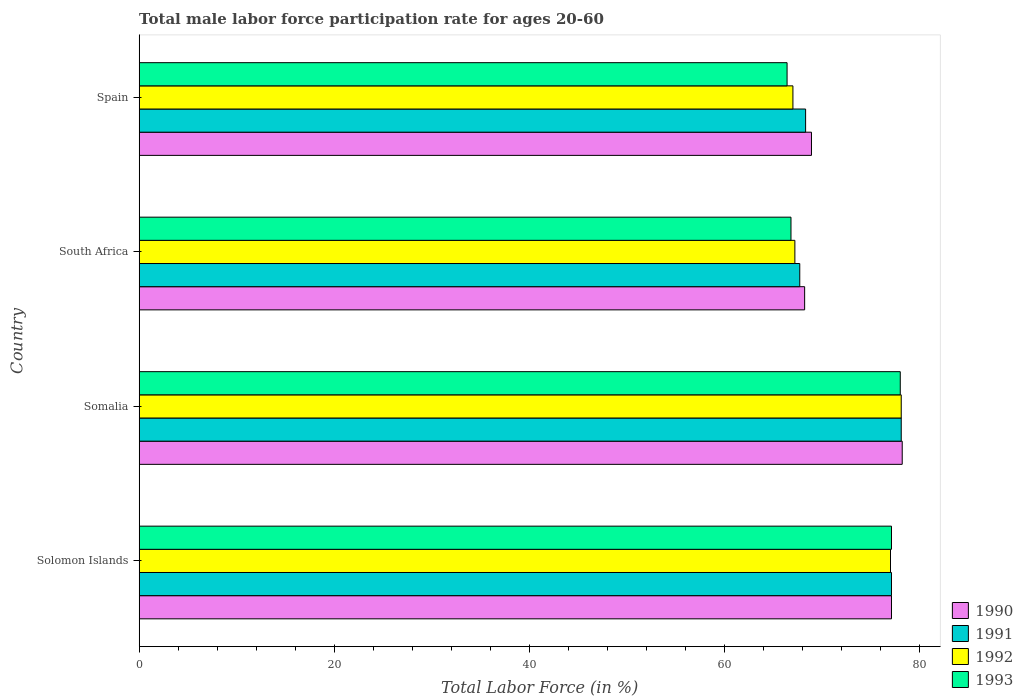How many groups of bars are there?
Ensure brevity in your answer.  4. Are the number of bars on each tick of the Y-axis equal?
Provide a short and direct response. Yes. How many bars are there on the 2nd tick from the bottom?
Provide a short and direct response. 4. What is the label of the 2nd group of bars from the top?
Keep it short and to the point. South Africa. What is the male labor force participation rate in 1992 in Somalia?
Provide a short and direct response. 78.1. Across all countries, what is the minimum male labor force participation rate in 1991?
Provide a succinct answer. 67.7. In which country was the male labor force participation rate in 1993 maximum?
Ensure brevity in your answer.  Somalia. What is the total male labor force participation rate in 1992 in the graph?
Your answer should be compact. 289.3. What is the difference between the male labor force participation rate in 1992 in Solomon Islands and that in Spain?
Your response must be concise. 10. What is the difference between the male labor force participation rate in 1991 in Somalia and the male labor force participation rate in 1993 in South Africa?
Offer a very short reply. 11.3. What is the average male labor force participation rate in 1990 per country?
Your answer should be very brief. 73.1. What is the difference between the male labor force participation rate in 1991 and male labor force participation rate in 1990 in Spain?
Offer a very short reply. -0.6. What is the ratio of the male labor force participation rate in 1993 in Solomon Islands to that in Somalia?
Provide a succinct answer. 0.99. Is the difference between the male labor force participation rate in 1991 in Solomon Islands and Spain greater than the difference between the male labor force participation rate in 1990 in Solomon Islands and Spain?
Offer a terse response. Yes. What is the difference between the highest and the second highest male labor force participation rate in 1992?
Your answer should be very brief. 1.1. In how many countries, is the male labor force participation rate in 1992 greater than the average male labor force participation rate in 1992 taken over all countries?
Your answer should be compact. 2. Is it the case that in every country, the sum of the male labor force participation rate in 1990 and male labor force participation rate in 1992 is greater than the sum of male labor force participation rate in 1993 and male labor force participation rate in 1991?
Provide a succinct answer. No. What does the 3rd bar from the bottom in South Africa represents?
Provide a short and direct response. 1992. Are all the bars in the graph horizontal?
Your answer should be very brief. Yes. Does the graph contain any zero values?
Your response must be concise. No. Does the graph contain grids?
Provide a short and direct response. No. How are the legend labels stacked?
Offer a very short reply. Vertical. What is the title of the graph?
Your answer should be very brief. Total male labor force participation rate for ages 20-60. Does "1983" appear as one of the legend labels in the graph?
Ensure brevity in your answer.  No. What is the label or title of the X-axis?
Make the answer very short. Total Labor Force (in %). What is the Total Labor Force (in %) of 1990 in Solomon Islands?
Ensure brevity in your answer.  77.1. What is the Total Labor Force (in %) of 1991 in Solomon Islands?
Your answer should be very brief. 77.1. What is the Total Labor Force (in %) in 1992 in Solomon Islands?
Your answer should be very brief. 77. What is the Total Labor Force (in %) in 1993 in Solomon Islands?
Give a very brief answer. 77.1. What is the Total Labor Force (in %) of 1990 in Somalia?
Provide a short and direct response. 78.2. What is the Total Labor Force (in %) in 1991 in Somalia?
Your answer should be compact. 78.1. What is the Total Labor Force (in %) of 1992 in Somalia?
Provide a short and direct response. 78.1. What is the Total Labor Force (in %) in 1990 in South Africa?
Ensure brevity in your answer.  68.2. What is the Total Labor Force (in %) of 1991 in South Africa?
Your response must be concise. 67.7. What is the Total Labor Force (in %) of 1992 in South Africa?
Offer a very short reply. 67.2. What is the Total Labor Force (in %) of 1993 in South Africa?
Keep it short and to the point. 66.8. What is the Total Labor Force (in %) of 1990 in Spain?
Your response must be concise. 68.9. What is the Total Labor Force (in %) of 1991 in Spain?
Ensure brevity in your answer.  68.3. What is the Total Labor Force (in %) of 1993 in Spain?
Ensure brevity in your answer.  66.4. Across all countries, what is the maximum Total Labor Force (in %) in 1990?
Ensure brevity in your answer.  78.2. Across all countries, what is the maximum Total Labor Force (in %) in 1991?
Your answer should be compact. 78.1. Across all countries, what is the maximum Total Labor Force (in %) of 1992?
Give a very brief answer. 78.1. Across all countries, what is the maximum Total Labor Force (in %) of 1993?
Offer a terse response. 78. Across all countries, what is the minimum Total Labor Force (in %) of 1990?
Offer a very short reply. 68.2. Across all countries, what is the minimum Total Labor Force (in %) in 1991?
Your answer should be very brief. 67.7. Across all countries, what is the minimum Total Labor Force (in %) of 1992?
Provide a succinct answer. 67. Across all countries, what is the minimum Total Labor Force (in %) in 1993?
Offer a very short reply. 66.4. What is the total Total Labor Force (in %) of 1990 in the graph?
Provide a short and direct response. 292.4. What is the total Total Labor Force (in %) of 1991 in the graph?
Provide a succinct answer. 291.2. What is the total Total Labor Force (in %) of 1992 in the graph?
Provide a succinct answer. 289.3. What is the total Total Labor Force (in %) of 1993 in the graph?
Offer a very short reply. 288.3. What is the difference between the Total Labor Force (in %) of 1991 in Solomon Islands and that in Somalia?
Your response must be concise. -1. What is the difference between the Total Labor Force (in %) of 1992 in Solomon Islands and that in Somalia?
Offer a terse response. -1.1. What is the difference between the Total Labor Force (in %) in 1990 in Solomon Islands and that in South Africa?
Give a very brief answer. 8.9. What is the difference between the Total Labor Force (in %) in 1991 in Solomon Islands and that in South Africa?
Your answer should be compact. 9.4. What is the difference between the Total Labor Force (in %) of 1992 in Solomon Islands and that in South Africa?
Give a very brief answer. 9.8. What is the difference between the Total Labor Force (in %) of 1990 in Solomon Islands and that in Spain?
Give a very brief answer. 8.2. What is the difference between the Total Labor Force (in %) in 1991 in Solomon Islands and that in Spain?
Ensure brevity in your answer.  8.8. What is the difference between the Total Labor Force (in %) of 1992 in Solomon Islands and that in Spain?
Provide a short and direct response. 10. What is the difference between the Total Labor Force (in %) of 1993 in Solomon Islands and that in Spain?
Provide a short and direct response. 10.7. What is the difference between the Total Labor Force (in %) of 1990 in Somalia and that in South Africa?
Your answer should be very brief. 10. What is the difference between the Total Labor Force (in %) in 1992 in Somalia and that in South Africa?
Offer a very short reply. 10.9. What is the difference between the Total Labor Force (in %) in 1993 in Somalia and that in South Africa?
Offer a very short reply. 11.2. What is the difference between the Total Labor Force (in %) of 1990 in South Africa and that in Spain?
Make the answer very short. -0.7. What is the difference between the Total Labor Force (in %) in 1991 in South Africa and that in Spain?
Provide a succinct answer. -0.6. What is the difference between the Total Labor Force (in %) of 1992 in South Africa and that in Spain?
Your answer should be compact. 0.2. What is the difference between the Total Labor Force (in %) of 1990 in Solomon Islands and the Total Labor Force (in %) of 1991 in Somalia?
Your answer should be compact. -1. What is the difference between the Total Labor Force (in %) in 1990 in Solomon Islands and the Total Labor Force (in %) in 1992 in Somalia?
Give a very brief answer. -1. What is the difference between the Total Labor Force (in %) in 1991 in Solomon Islands and the Total Labor Force (in %) in 1992 in Somalia?
Provide a short and direct response. -1. What is the difference between the Total Labor Force (in %) of 1990 in Solomon Islands and the Total Labor Force (in %) of 1991 in South Africa?
Your response must be concise. 9.4. What is the difference between the Total Labor Force (in %) in 1990 in Solomon Islands and the Total Labor Force (in %) in 1993 in South Africa?
Keep it short and to the point. 10.3. What is the difference between the Total Labor Force (in %) in 1991 in Solomon Islands and the Total Labor Force (in %) in 1993 in South Africa?
Keep it short and to the point. 10.3. What is the difference between the Total Labor Force (in %) in 1990 in Solomon Islands and the Total Labor Force (in %) in 1991 in Spain?
Provide a succinct answer. 8.8. What is the difference between the Total Labor Force (in %) of 1991 in Solomon Islands and the Total Labor Force (in %) of 1993 in Spain?
Give a very brief answer. 10.7. What is the difference between the Total Labor Force (in %) in 1992 in Solomon Islands and the Total Labor Force (in %) in 1993 in Spain?
Ensure brevity in your answer.  10.6. What is the difference between the Total Labor Force (in %) of 1990 in Somalia and the Total Labor Force (in %) of 1991 in South Africa?
Provide a succinct answer. 10.5. What is the difference between the Total Labor Force (in %) in 1991 in Somalia and the Total Labor Force (in %) in 1993 in South Africa?
Your answer should be very brief. 11.3. What is the difference between the Total Labor Force (in %) of 1990 in Somalia and the Total Labor Force (in %) of 1992 in Spain?
Make the answer very short. 11.2. What is the difference between the Total Labor Force (in %) of 1992 in Somalia and the Total Labor Force (in %) of 1993 in Spain?
Offer a very short reply. 11.7. What is the difference between the Total Labor Force (in %) in 1990 in South Africa and the Total Labor Force (in %) in 1993 in Spain?
Your answer should be compact. 1.8. What is the average Total Labor Force (in %) of 1990 per country?
Your response must be concise. 73.1. What is the average Total Labor Force (in %) of 1991 per country?
Make the answer very short. 72.8. What is the average Total Labor Force (in %) of 1992 per country?
Offer a very short reply. 72.33. What is the average Total Labor Force (in %) in 1993 per country?
Provide a short and direct response. 72.08. What is the difference between the Total Labor Force (in %) of 1990 and Total Labor Force (in %) of 1991 in Solomon Islands?
Ensure brevity in your answer.  0. What is the difference between the Total Labor Force (in %) in 1990 and Total Labor Force (in %) in 1992 in Solomon Islands?
Make the answer very short. 0.1. What is the difference between the Total Labor Force (in %) of 1991 and Total Labor Force (in %) of 1992 in Solomon Islands?
Offer a very short reply. 0.1. What is the difference between the Total Labor Force (in %) of 1991 and Total Labor Force (in %) of 1993 in Solomon Islands?
Your answer should be compact. 0. What is the difference between the Total Labor Force (in %) in 1990 and Total Labor Force (in %) in 1993 in South Africa?
Your answer should be very brief. 1.4. What is the difference between the Total Labor Force (in %) in 1991 and Total Labor Force (in %) in 1993 in South Africa?
Offer a terse response. 0.9. What is the difference between the Total Labor Force (in %) of 1991 and Total Labor Force (in %) of 1992 in Spain?
Your answer should be compact. 1.3. What is the difference between the Total Labor Force (in %) of 1991 and Total Labor Force (in %) of 1993 in Spain?
Your answer should be very brief. 1.9. What is the ratio of the Total Labor Force (in %) of 1990 in Solomon Islands to that in Somalia?
Keep it short and to the point. 0.99. What is the ratio of the Total Labor Force (in %) in 1991 in Solomon Islands to that in Somalia?
Make the answer very short. 0.99. What is the ratio of the Total Labor Force (in %) of 1992 in Solomon Islands to that in Somalia?
Your response must be concise. 0.99. What is the ratio of the Total Labor Force (in %) in 1993 in Solomon Islands to that in Somalia?
Your response must be concise. 0.99. What is the ratio of the Total Labor Force (in %) of 1990 in Solomon Islands to that in South Africa?
Your response must be concise. 1.13. What is the ratio of the Total Labor Force (in %) of 1991 in Solomon Islands to that in South Africa?
Keep it short and to the point. 1.14. What is the ratio of the Total Labor Force (in %) of 1992 in Solomon Islands to that in South Africa?
Your answer should be compact. 1.15. What is the ratio of the Total Labor Force (in %) of 1993 in Solomon Islands to that in South Africa?
Keep it short and to the point. 1.15. What is the ratio of the Total Labor Force (in %) in 1990 in Solomon Islands to that in Spain?
Your answer should be very brief. 1.12. What is the ratio of the Total Labor Force (in %) in 1991 in Solomon Islands to that in Spain?
Your answer should be compact. 1.13. What is the ratio of the Total Labor Force (in %) in 1992 in Solomon Islands to that in Spain?
Offer a terse response. 1.15. What is the ratio of the Total Labor Force (in %) of 1993 in Solomon Islands to that in Spain?
Ensure brevity in your answer.  1.16. What is the ratio of the Total Labor Force (in %) in 1990 in Somalia to that in South Africa?
Provide a short and direct response. 1.15. What is the ratio of the Total Labor Force (in %) in 1991 in Somalia to that in South Africa?
Offer a terse response. 1.15. What is the ratio of the Total Labor Force (in %) of 1992 in Somalia to that in South Africa?
Provide a short and direct response. 1.16. What is the ratio of the Total Labor Force (in %) of 1993 in Somalia to that in South Africa?
Offer a very short reply. 1.17. What is the ratio of the Total Labor Force (in %) in 1990 in Somalia to that in Spain?
Your answer should be compact. 1.14. What is the ratio of the Total Labor Force (in %) of 1991 in Somalia to that in Spain?
Give a very brief answer. 1.14. What is the ratio of the Total Labor Force (in %) of 1992 in Somalia to that in Spain?
Your answer should be very brief. 1.17. What is the ratio of the Total Labor Force (in %) in 1993 in Somalia to that in Spain?
Provide a succinct answer. 1.17. What is the ratio of the Total Labor Force (in %) of 1990 in South Africa to that in Spain?
Make the answer very short. 0.99. What is the difference between the highest and the second highest Total Labor Force (in %) in 1990?
Give a very brief answer. 1.1. What is the difference between the highest and the second highest Total Labor Force (in %) in 1993?
Offer a very short reply. 0.9. What is the difference between the highest and the lowest Total Labor Force (in %) of 1990?
Give a very brief answer. 10. What is the difference between the highest and the lowest Total Labor Force (in %) of 1991?
Your response must be concise. 10.4. What is the difference between the highest and the lowest Total Labor Force (in %) of 1993?
Provide a succinct answer. 11.6. 